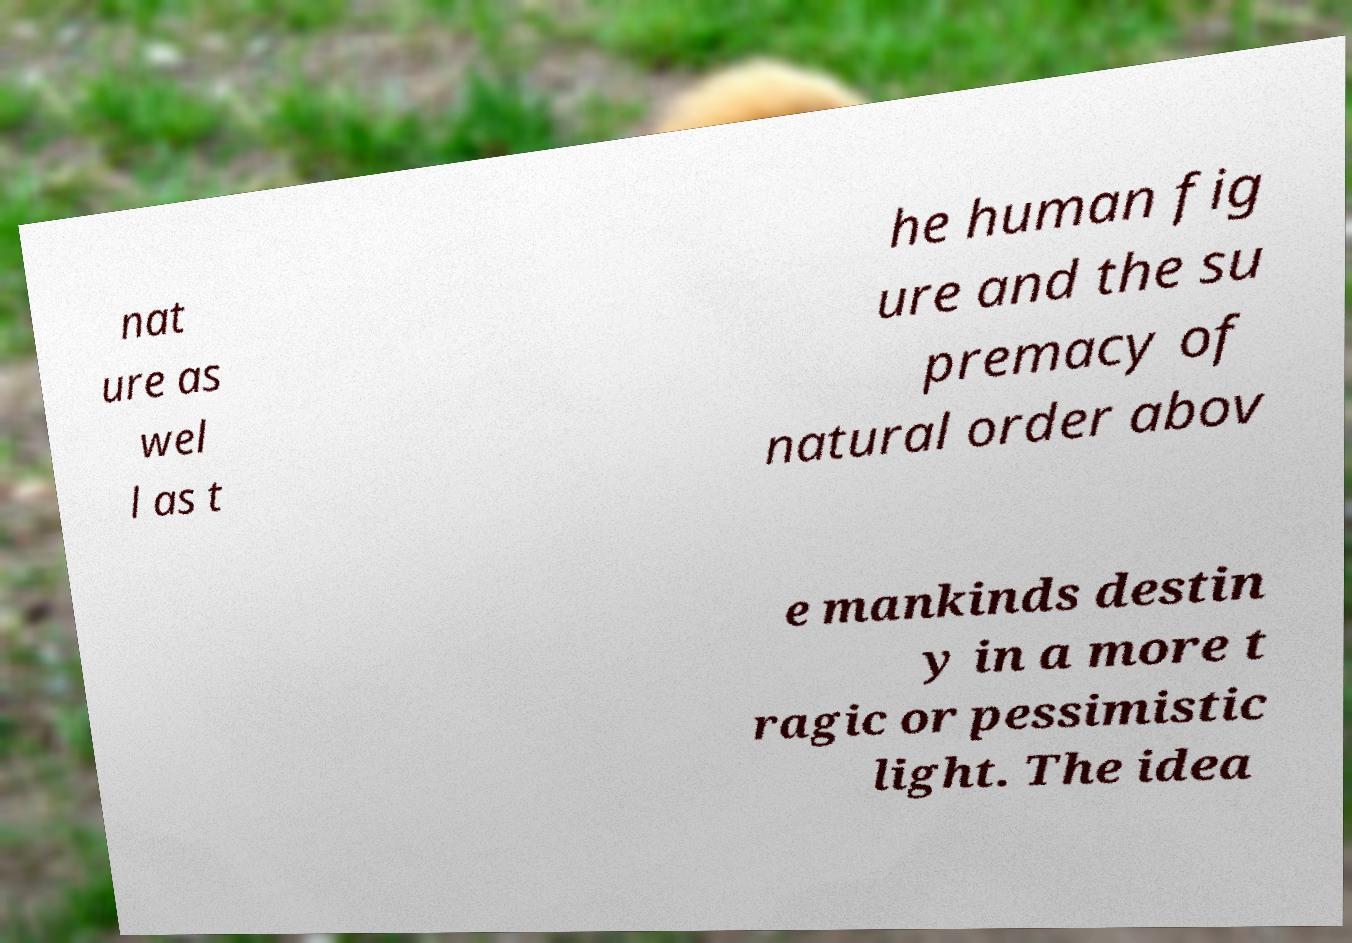Please read and relay the text visible in this image. What does it say? nat ure as wel l as t he human fig ure and the su premacy of natural order abov e mankinds destin y in a more t ragic or pessimistic light. The idea 